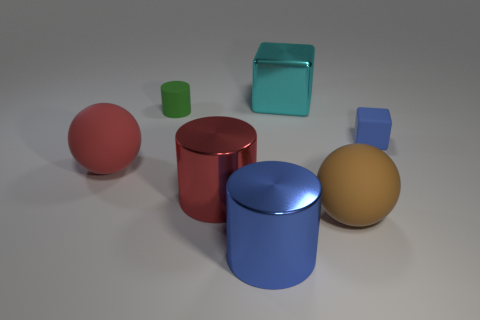How many other objects are the same material as the red cylinder?
Your response must be concise. 2. Is the big ball that is left of the brown matte sphere made of the same material as the blue object to the right of the big cyan object?
Provide a succinct answer. Yes. How many big metallic objects are in front of the matte cylinder and right of the large red shiny thing?
Your answer should be compact. 1. Are there any other tiny brown things that have the same shape as the brown matte thing?
Your answer should be compact. No. What is the shape of the red shiny thing that is the same size as the brown sphere?
Make the answer very short. Cylinder. Are there an equal number of red matte spheres in front of the large brown ball and large blue cylinders that are behind the large red metallic cylinder?
Offer a very short reply. Yes. How big is the blue object that is in front of the small blue matte cube that is behind the large blue metal cylinder?
Offer a very short reply. Large. Are there any purple metal blocks of the same size as the green cylinder?
Give a very brief answer. No. What is the color of the other small thing that is the same material as the tiny blue thing?
Offer a terse response. Green. Is the number of tiny cylinders less than the number of large cyan matte cylinders?
Keep it short and to the point. No. 